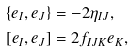<formula> <loc_0><loc_0><loc_500><loc_500>& \{ e _ { I } , e _ { J } \} = - 2 \eta _ { I J } , \\ & [ e _ { I } , e _ { J } ] = 2 f _ { I J K } e _ { K } ,</formula> 